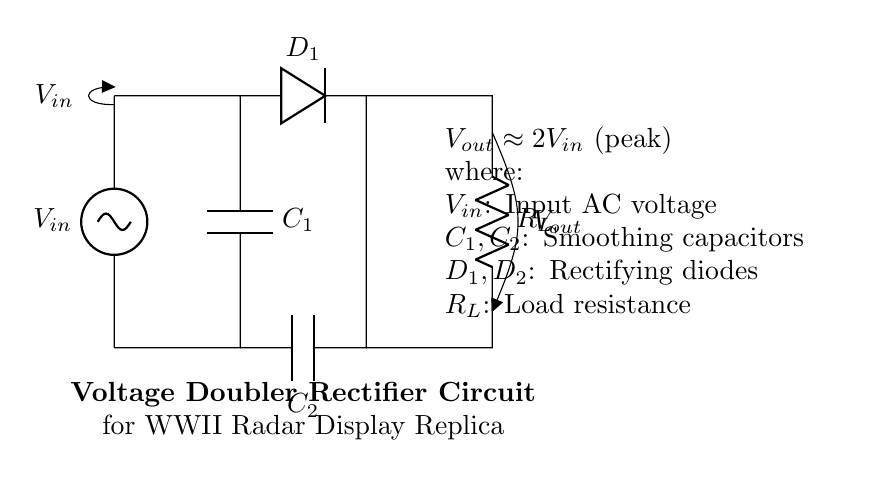What is the type of circuit represented? The circuit is a voltage doubler rectifier, as indicated by the description and components used, specifically designed to increase the output voltage.
Answer: Voltage doubler rectifier What do the capacitors C1 and C2 do in this circuit? The capacitors C1 and C2 serve as smoothing capacitors which help store and filter the output voltage to reduce ripple, providing a more stable DC output.
Answer: Smoothing capacitors What is the expected output voltage in relation to the input voltage? The output voltage is approximately double the input voltage peak according to the information provided in the circuit description.
Answer: 2 Vin What are the components used for rectification in this circuit? The components used for rectification in this circuit are the diodes, identified as D1, as they allow current to flow in one direction only, converting AC to DC.
Answer: D1 What does the load resistance R_L represent? The load resistance R_L represents the component that consumes power from the output of the rectifier circuit, simulating the load of the WWII radar display system.
Answer: Load resistance Which component indicates the input voltage? The component indicating the input voltage is labeled as a voltage source, specifically labeled V_in, which provides the AC voltage required for the circuit operation.
Answer: V_in 